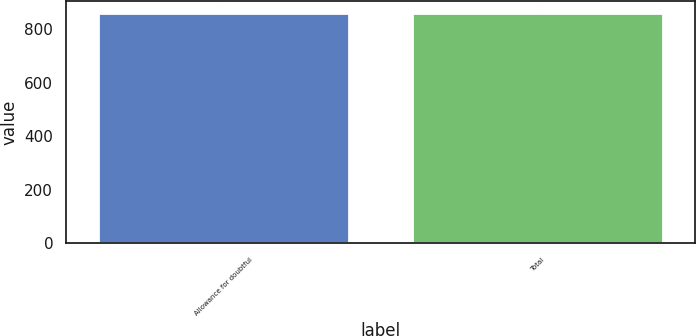<chart> <loc_0><loc_0><loc_500><loc_500><bar_chart><fcel>Allowance for doubtful<fcel>Total<nl><fcel>861<fcel>861.1<nl></chart> 